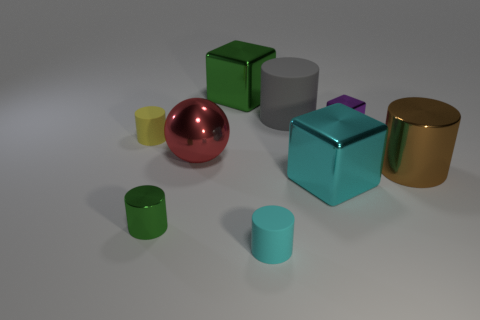Subtract all green cylinders. How many cylinders are left? 4 Subtract all purple cylinders. Subtract all gray cubes. How many cylinders are left? 5 Add 1 large metal spheres. How many objects exist? 10 Subtract all balls. How many objects are left? 8 Subtract 1 cyan cubes. How many objects are left? 8 Subtract all big yellow matte balls. Subtract all brown shiny objects. How many objects are left? 8 Add 4 red metal objects. How many red metal objects are left? 5 Add 2 yellow matte cylinders. How many yellow matte cylinders exist? 3 